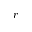Convert formula to latex. <formula><loc_0><loc_0><loc_500><loc_500>r</formula> 